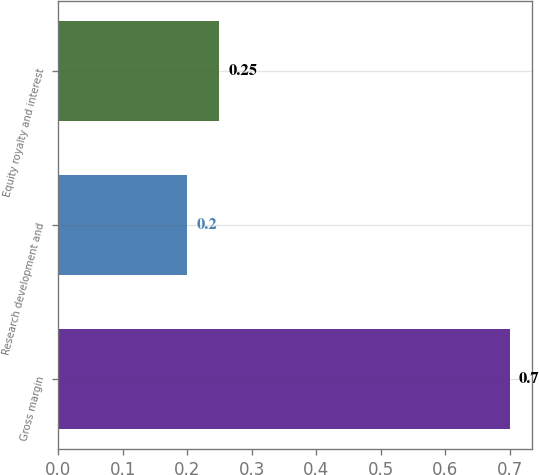Convert chart. <chart><loc_0><loc_0><loc_500><loc_500><bar_chart><fcel>Gross margin<fcel>Research development and<fcel>Equity royalty and interest<nl><fcel>0.7<fcel>0.2<fcel>0.25<nl></chart> 